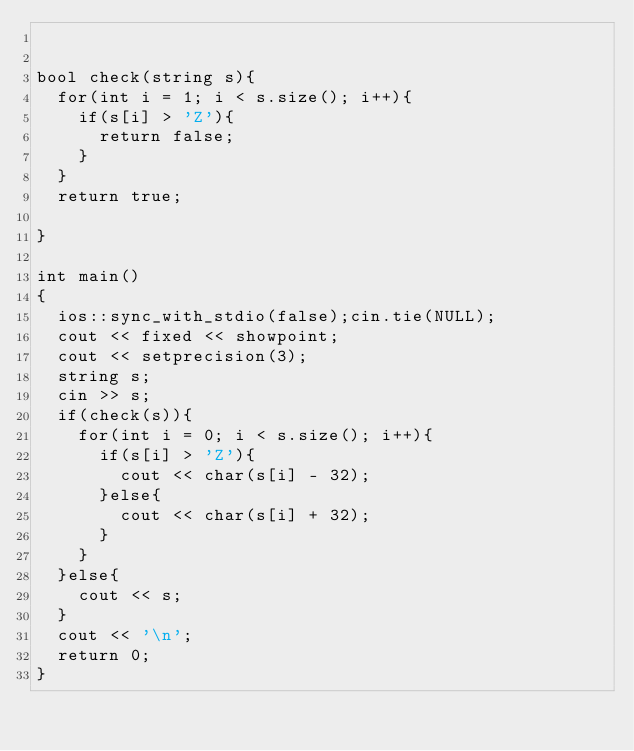Convert code to text. <code><loc_0><loc_0><loc_500><loc_500><_C++_>

bool check(string s){
	for(int i = 1; i < s.size(); i++){
		if(s[i] > 'Z'){
			return false;
		}
	}
	return true;
	
}

int main()
{
	ios::sync_with_stdio(false);cin.tie(NULL);
	cout << fixed << showpoint;
	cout << setprecision(3);
	string s;
	cin >> s;
	if(check(s)){
		for(int i = 0; i < s.size(); i++){
			if(s[i] > 'Z'){
				cout << char(s[i] - 32);
			}else{
				cout << char(s[i] + 32);
			}
		}
	}else{
		cout << s;
	}
	cout << '\n';
	return 0;
}


</code> 